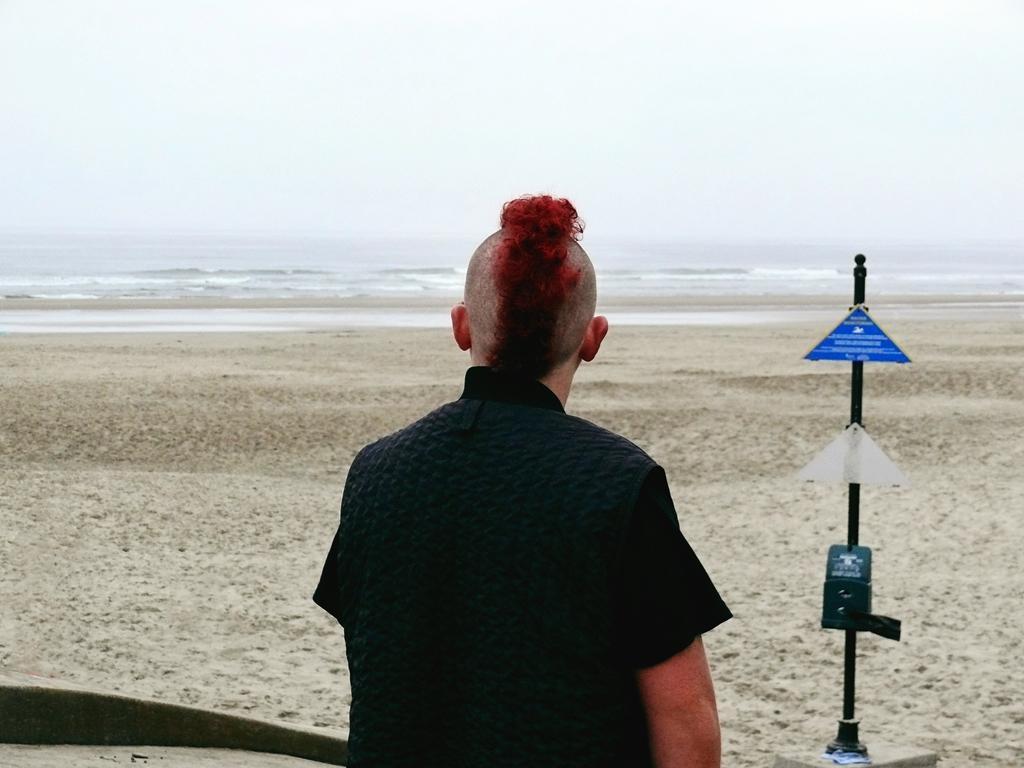Please provide a concise description of this image. In this picture we can see a person with red hair sitting on the sand and looking at the sea. On the right side we have sign boards. 